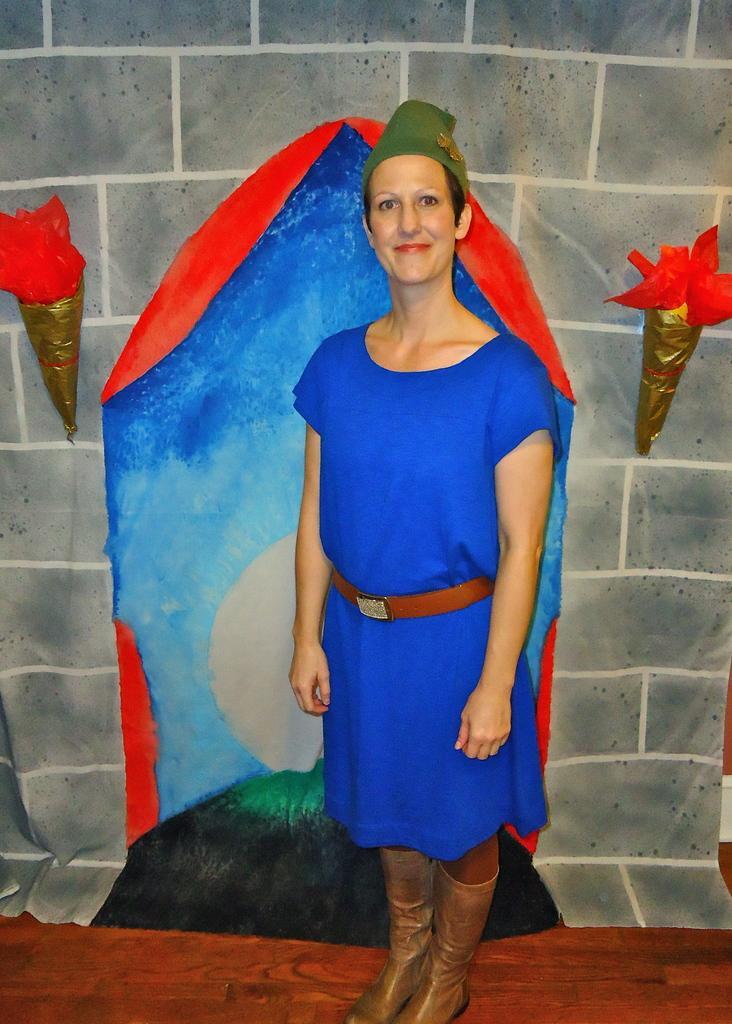Describe this image in one or two sentences. In this picture there is a woman in the center. She is wearing a blue dress and a brown belt. Behind her, there is a cloth. On the cloth there is some painting. Towards the left and right there are two objects. 